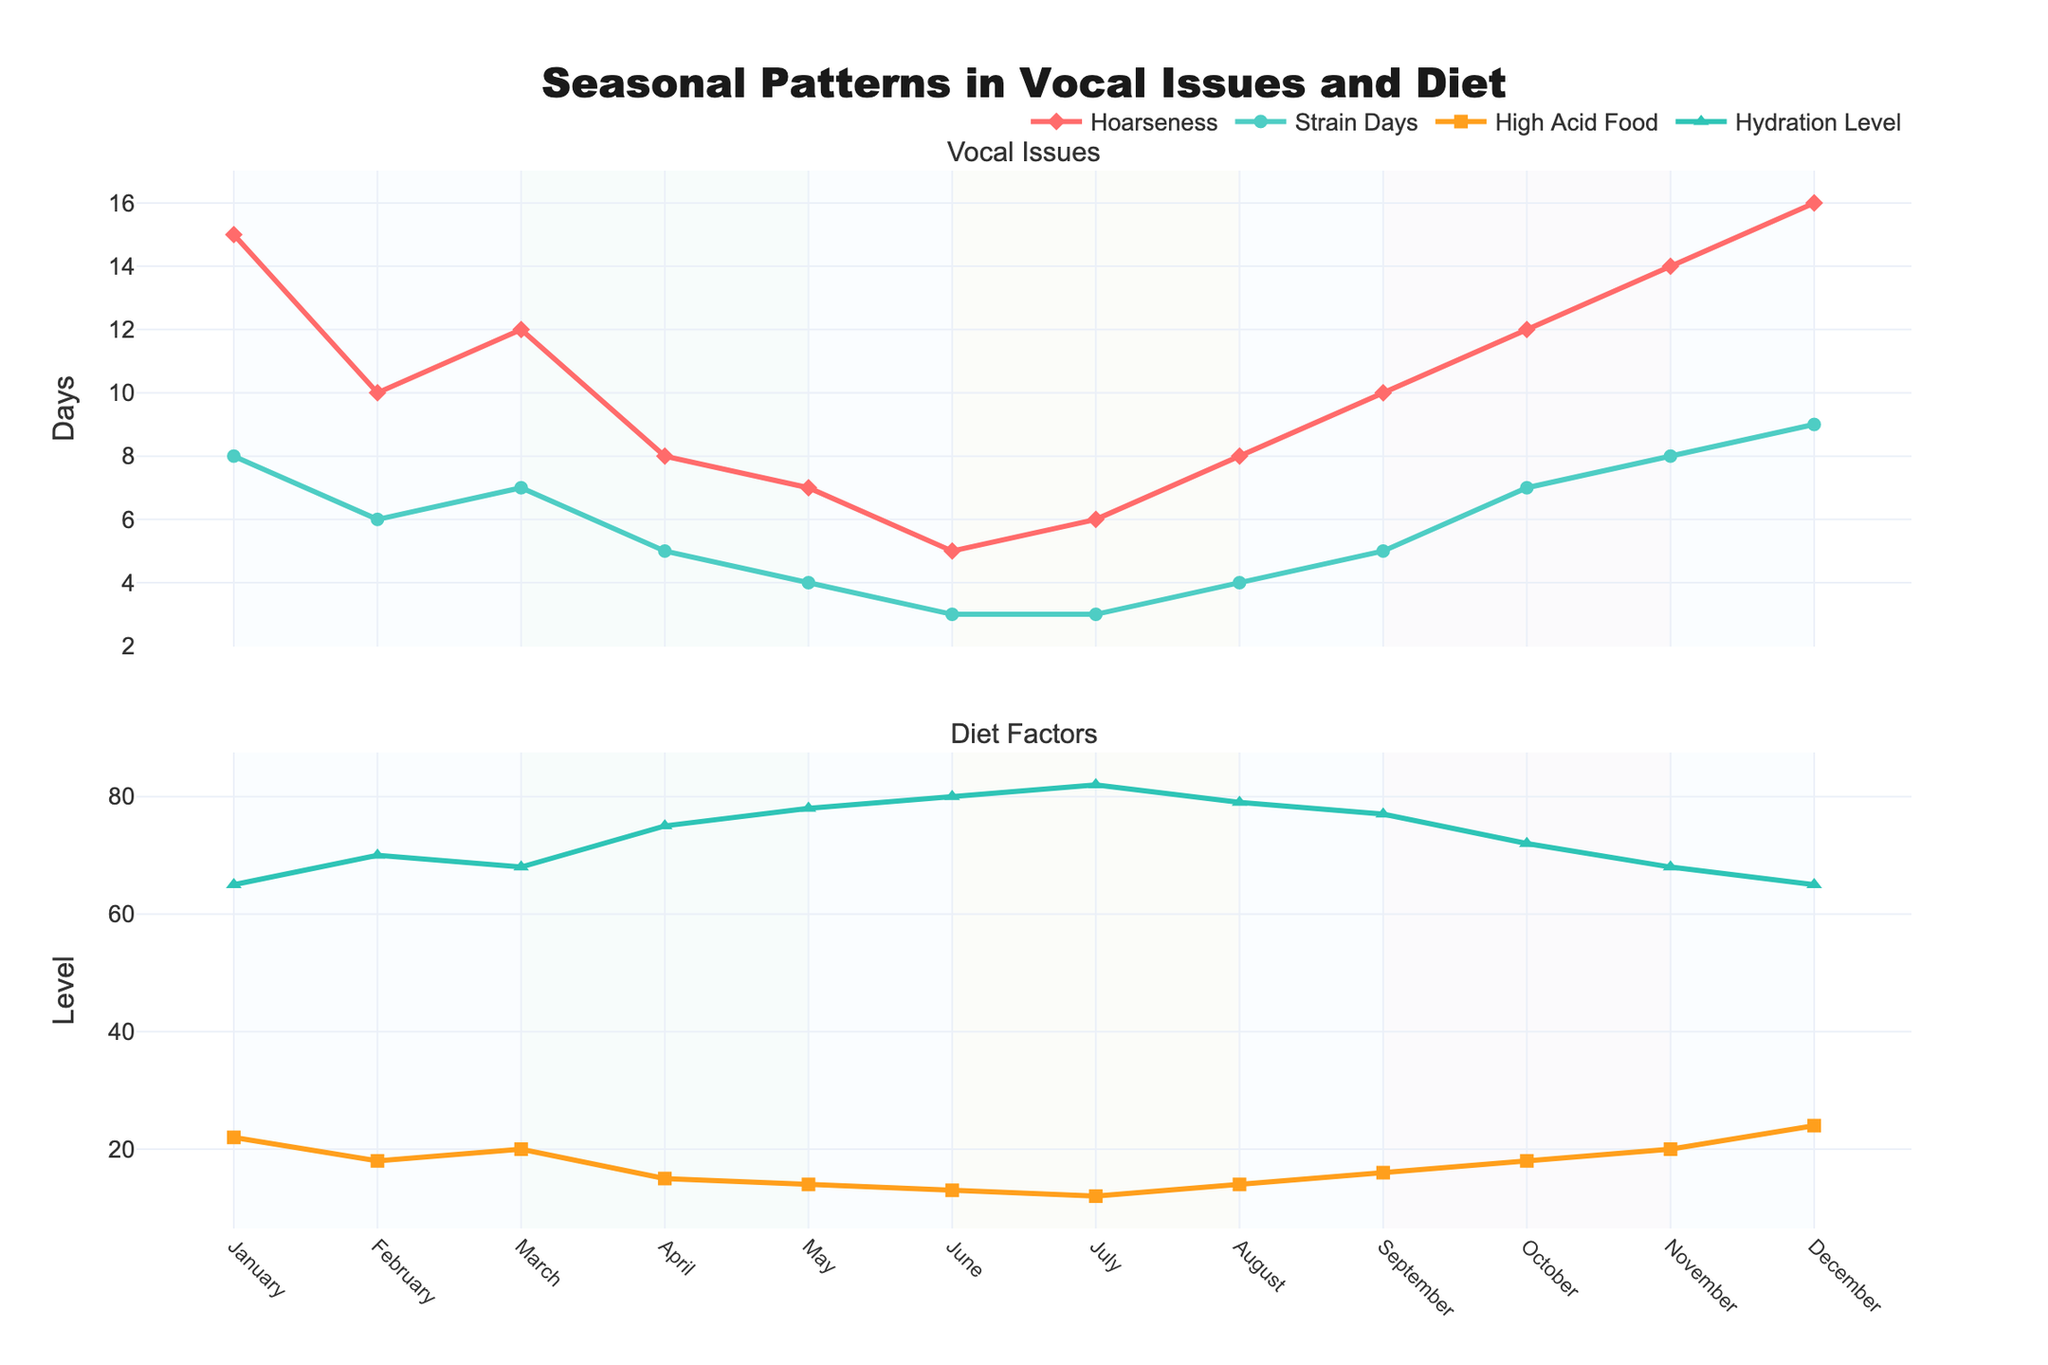What is the title of the figure? The title of the figure is displayed at the top of the plot.
Answer: Seasonal Patterns in Vocal Issues and Diet How many lines are in the plot? There are two subplots with two lines each, representing different data series.
Answer: Four Which month has the highest number of hoarseness days? The plot shows hoarseness days peaking in December.
Answer: December What is the overall trend of high acid food consumption from January to December? The line representing high acid food consumption starts at 22 in January, decreases, and then peaks again at 24 in December.
Answer: Decreasing and then increasing Compare the hydration level in winter and summer months. Which season has a higher average hydration level? Winter months (January, February, December) have hydration levels of 65, 70, and 65. Summer months (June, July, August) have hydration levels of 80, 82, and 79. Average for winter: (65 + 70 + 65)/3 ≈ 67. Average for summer: (80 + 82 + 79)/3 ≈ 80.3.
Answer: Summer How does the number of strain days in April compare to that in October? The subplot shows strain days are 5 in April and 7 in October.
Answer: October has more strain days than April What is the correlation between hydration level and high acid food consumption? Visually, there seems to be an inverse relationship; as high acid food consumption increases, hydration level decreases.
Answer: Inverse relationship Which season has the most significant variation in hoarseness days? Reviewing the plot, winter months show the highest variability with values ranging from 10 to 16.
Answer: Winter Are there any months where vocal strain days and high acid food consumption have the same value? By looking at the individual data points, this occurs in November where both have a value of 8.
Answer: November What is the average hoarseness value over the spring months? Spring months are March, April, May with hoarseness values of 12, 8, 7. The average is (12 + 8 + 7)/3 = 27/3 = 9.
Answer: 9 